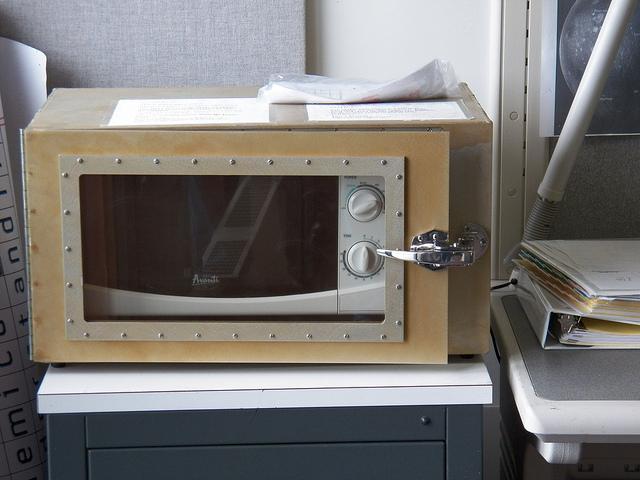Is there a case around the microwave?
Concise answer only. Yes. Is this a fridge?
Write a very short answer. No. Is a reflection seen?
Concise answer only. Yes. 